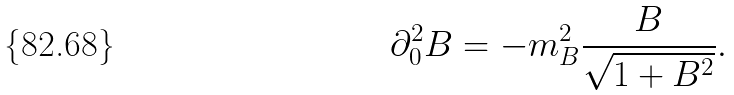Convert formula to latex. <formula><loc_0><loc_0><loc_500><loc_500>\partial _ { 0 } ^ { 2 } B = - m _ { B } ^ { 2 } \frac { B } { \sqrt { 1 + B ^ { 2 } } } .</formula> 